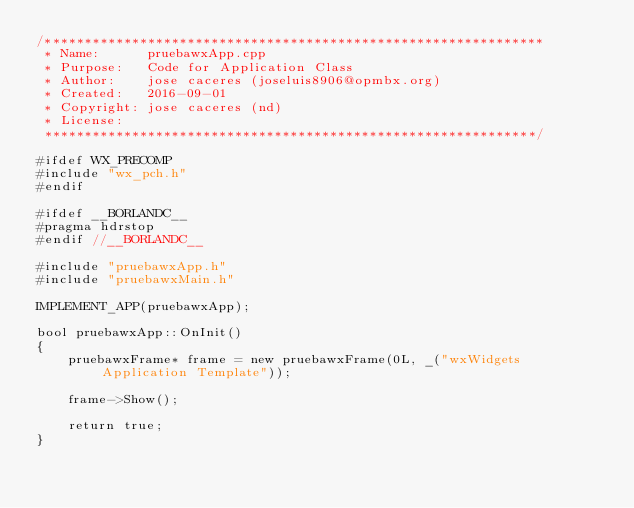Convert code to text. <code><loc_0><loc_0><loc_500><loc_500><_C++_>/***************************************************************
 * Name:      pruebawxApp.cpp
 * Purpose:   Code for Application Class
 * Author:    jose caceres (joseluis8906@opmbx.org)
 * Created:   2016-09-01
 * Copyright: jose caceres (nd)
 * License:
 **************************************************************/

#ifdef WX_PRECOMP
#include "wx_pch.h"
#endif

#ifdef __BORLANDC__
#pragma hdrstop
#endif //__BORLANDC__

#include "pruebawxApp.h"
#include "pruebawxMain.h"

IMPLEMENT_APP(pruebawxApp);

bool pruebawxApp::OnInit()
{
    pruebawxFrame* frame = new pruebawxFrame(0L, _("wxWidgets Application Template"));
    
    frame->Show();
    
    return true;
}
</code> 